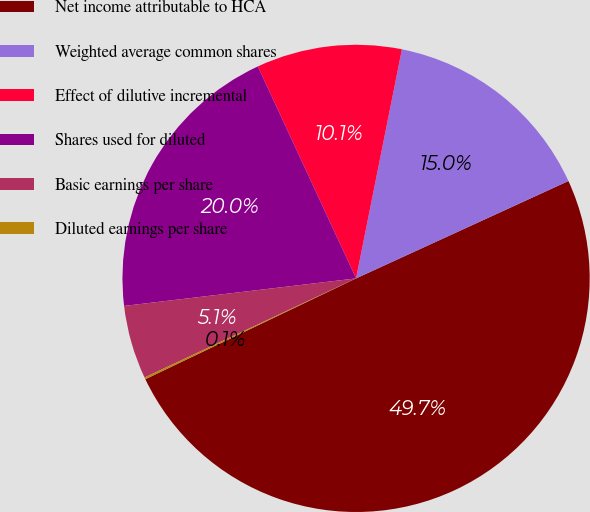<chart> <loc_0><loc_0><loc_500><loc_500><pie_chart><fcel>Net income attributable to HCA<fcel>Weighted average common shares<fcel>Effect of dilutive incremental<fcel>Shares used for diluted<fcel>Basic earnings per share<fcel>Diluted earnings per share<nl><fcel>49.73%<fcel>15.01%<fcel>10.05%<fcel>19.97%<fcel>5.09%<fcel>0.13%<nl></chart> 